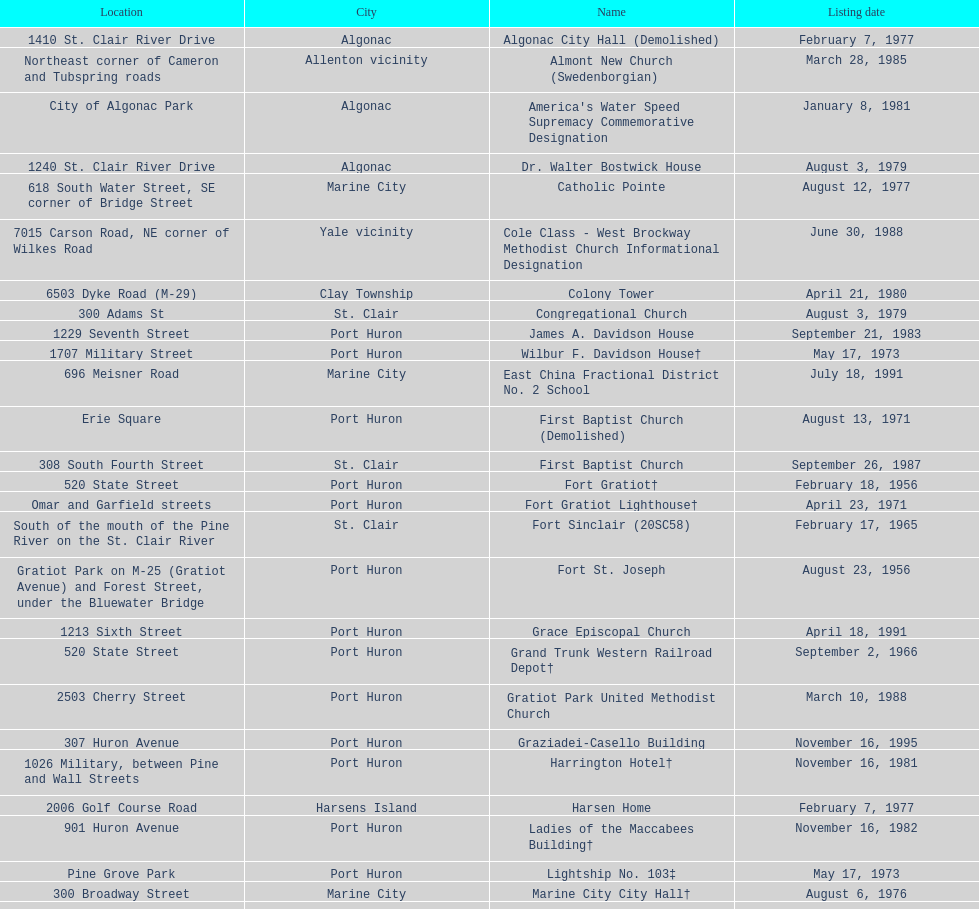Which city is home to the greatest number of historic sites, existing or demolished? Port Huron. 